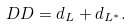<formula> <loc_0><loc_0><loc_500><loc_500>\ D D = d _ { L } + d _ { L ^ { * } } .</formula> 